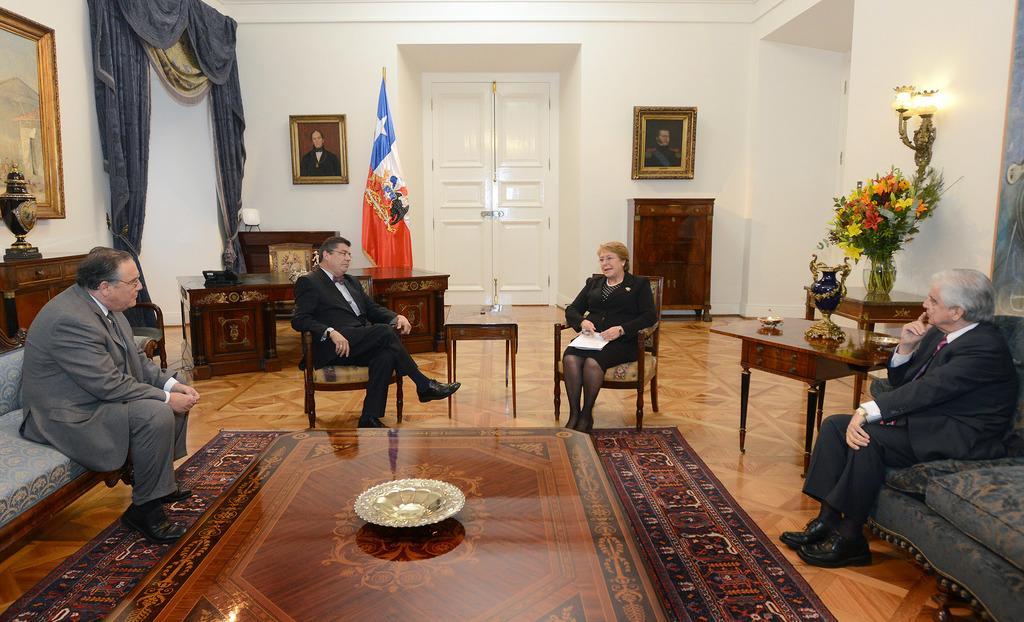In one or two sentences, can you explain what this image depicts? This picture shows four people, seated on the chairs we see a woman holding a paper in her hand. we see a flag and photo frames on the wall and we see a flower vase on the table 